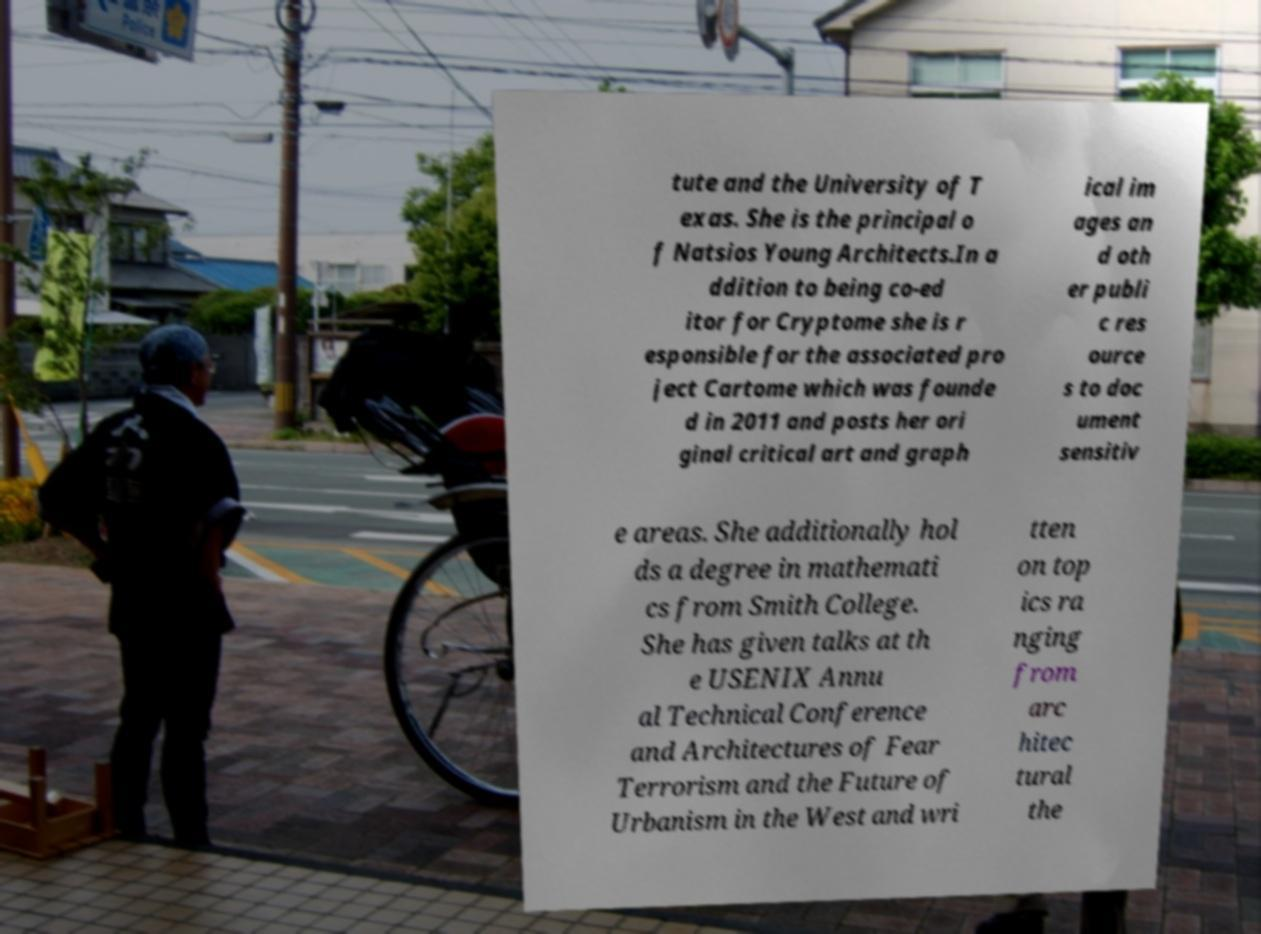Could you assist in decoding the text presented in this image and type it out clearly? tute and the University of T exas. She is the principal o f Natsios Young Architects.In a ddition to being co-ed itor for Cryptome she is r esponsible for the associated pro ject Cartome which was founde d in 2011 and posts her ori ginal critical art and graph ical im ages an d oth er publi c res ource s to doc ument sensitiv e areas. She additionally hol ds a degree in mathemati cs from Smith College. She has given talks at th e USENIX Annu al Technical Conference and Architectures of Fear Terrorism and the Future of Urbanism in the West and wri tten on top ics ra nging from arc hitec tural the 